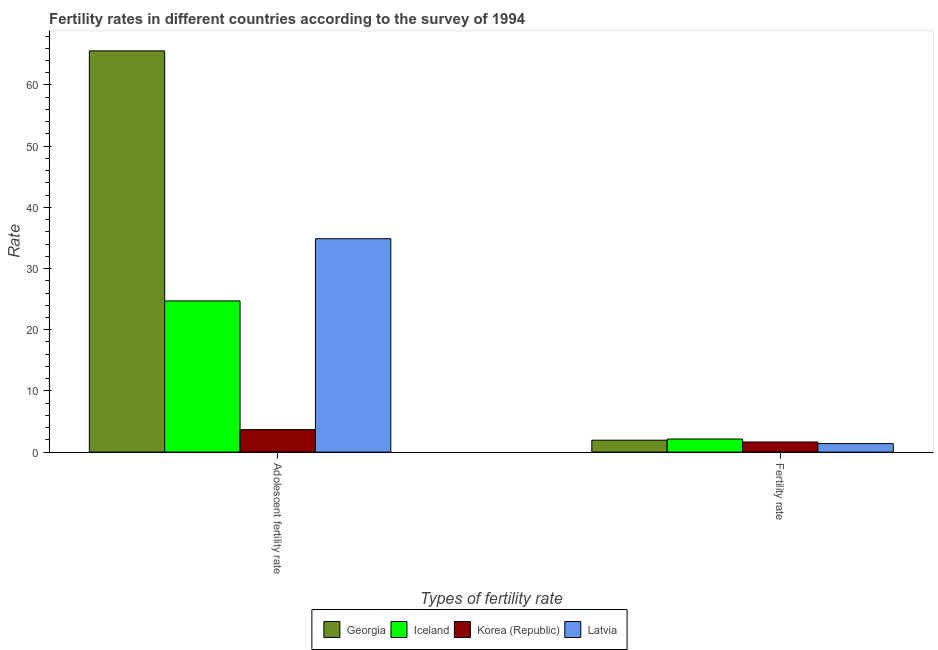How many groups of bars are there?
Your response must be concise. 2. Are the number of bars on each tick of the X-axis equal?
Give a very brief answer. Yes. What is the label of the 2nd group of bars from the left?
Keep it short and to the point. Fertility rate. What is the adolescent fertility rate in Latvia?
Offer a terse response. 34.88. Across all countries, what is the maximum fertility rate?
Your answer should be compact. 2.14. Across all countries, what is the minimum fertility rate?
Offer a very short reply. 1.39. In which country was the adolescent fertility rate maximum?
Provide a succinct answer. Georgia. In which country was the adolescent fertility rate minimum?
Keep it short and to the point. Korea (Republic). What is the total adolescent fertility rate in the graph?
Ensure brevity in your answer.  128.83. What is the difference between the adolescent fertility rate in Latvia and that in Iceland?
Offer a very short reply. 10.17. What is the difference between the fertility rate in Latvia and the adolescent fertility rate in Korea (Republic)?
Offer a very short reply. -2.29. What is the average adolescent fertility rate per country?
Give a very brief answer. 32.21. What is the difference between the adolescent fertility rate and fertility rate in Georgia?
Your answer should be very brief. 63.62. In how many countries, is the adolescent fertility rate greater than 26 ?
Give a very brief answer. 2. What is the ratio of the fertility rate in Iceland to that in Korea (Republic)?
Your answer should be compact. 1.29. Is the adolescent fertility rate in Korea (Republic) less than that in Iceland?
Provide a short and direct response. Yes. What does the 1st bar from the left in Fertility rate represents?
Your answer should be very brief. Georgia. What does the 1st bar from the right in Fertility rate represents?
Your response must be concise. Latvia. How many countries are there in the graph?
Your answer should be very brief. 4. What is the difference between two consecutive major ticks on the Y-axis?
Your answer should be very brief. 10. Where does the legend appear in the graph?
Your answer should be compact. Bottom center. What is the title of the graph?
Your answer should be very brief. Fertility rates in different countries according to the survey of 1994. Does "Qatar" appear as one of the legend labels in the graph?
Your answer should be compact. No. What is the label or title of the X-axis?
Make the answer very short. Types of fertility rate. What is the label or title of the Y-axis?
Provide a short and direct response. Rate. What is the Rate in Georgia in Adolescent fertility rate?
Your response must be concise. 65.57. What is the Rate of Iceland in Adolescent fertility rate?
Provide a short and direct response. 24.71. What is the Rate in Korea (Republic) in Adolescent fertility rate?
Keep it short and to the point. 3.68. What is the Rate in Latvia in Adolescent fertility rate?
Keep it short and to the point. 34.88. What is the Rate of Georgia in Fertility rate?
Give a very brief answer. 1.95. What is the Rate of Iceland in Fertility rate?
Offer a very short reply. 2.14. What is the Rate in Korea (Republic) in Fertility rate?
Ensure brevity in your answer.  1.66. What is the Rate in Latvia in Fertility rate?
Give a very brief answer. 1.39. Across all Types of fertility rate, what is the maximum Rate of Georgia?
Provide a short and direct response. 65.57. Across all Types of fertility rate, what is the maximum Rate of Iceland?
Make the answer very short. 24.71. Across all Types of fertility rate, what is the maximum Rate of Korea (Republic)?
Provide a short and direct response. 3.68. Across all Types of fertility rate, what is the maximum Rate of Latvia?
Keep it short and to the point. 34.88. Across all Types of fertility rate, what is the minimum Rate in Georgia?
Provide a short and direct response. 1.95. Across all Types of fertility rate, what is the minimum Rate of Iceland?
Your answer should be very brief. 2.14. Across all Types of fertility rate, what is the minimum Rate in Korea (Republic)?
Provide a succinct answer. 1.66. Across all Types of fertility rate, what is the minimum Rate in Latvia?
Offer a terse response. 1.39. What is the total Rate of Georgia in the graph?
Give a very brief answer. 67.52. What is the total Rate of Iceland in the graph?
Offer a very short reply. 26.85. What is the total Rate of Korea (Republic) in the graph?
Make the answer very short. 5.33. What is the total Rate of Latvia in the graph?
Provide a succinct answer. 36.27. What is the difference between the Rate in Georgia in Adolescent fertility rate and that in Fertility rate?
Make the answer very short. 63.62. What is the difference between the Rate of Iceland in Adolescent fertility rate and that in Fertility rate?
Keep it short and to the point. 22.57. What is the difference between the Rate of Korea (Republic) in Adolescent fertility rate and that in Fertility rate?
Keep it short and to the point. 2.02. What is the difference between the Rate of Latvia in Adolescent fertility rate and that in Fertility rate?
Keep it short and to the point. 33.49. What is the difference between the Rate in Georgia in Adolescent fertility rate and the Rate in Iceland in Fertility rate?
Make the answer very short. 63.43. What is the difference between the Rate in Georgia in Adolescent fertility rate and the Rate in Korea (Republic) in Fertility rate?
Offer a very short reply. 63.91. What is the difference between the Rate of Georgia in Adolescent fertility rate and the Rate of Latvia in Fertility rate?
Offer a very short reply. 64.18. What is the difference between the Rate of Iceland in Adolescent fertility rate and the Rate of Korea (Republic) in Fertility rate?
Give a very brief answer. 23.05. What is the difference between the Rate in Iceland in Adolescent fertility rate and the Rate in Latvia in Fertility rate?
Provide a short and direct response. 23.32. What is the difference between the Rate in Korea (Republic) in Adolescent fertility rate and the Rate in Latvia in Fertility rate?
Provide a short and direct response. 2.29. What is the average Rate in Georgia per Types of fertility rate?
Keep it short and to the point. 33.76. What is the average Rate in Iceland per Types of fertility rate?
Keep it short and to the point. 13.42. What is the average Rate in Korea (Republic) per Types of fertility rate?
Your answer should be very brief. 2.67. What is the average Rate in Latvia per Types of fertility rate?
Your answer should be very brief. 18.13. What is the difference between the Rate in Georgia and Rate in Iceland in Adolescent fertility rate?
Ensure brevity in your answer.  40.86. What is the difference between the Rate of Georgia and Rate of Korea (Republic) in Adolescent fertility rate?
Provide a short and direct response. 61.89. What is the difference between the Rate in Georgia and Rate in Latvia in Adolescent fertility rate?
Provide a short and direct response. 30.69. What is the difference between the Rate of Iceland and Rate of Korea (Republic) in Adolescent fertility rate?
Your answer should be very brief. 21.03. What is the difference between the Rate of Iceland and Rate of Latvia in Adolescent fertility rate?
Provide a succinct answer. -10.17. What is the difference between the Rate of Korea (Republic) and Rate of Latvia in Adolescent fertility rate?
Offer a terse response. -31.2. What is the difference between the Rate in Georgia and Rate in Iceland in Fertility rate?
Provide a succinct answer. -0.19. What is the difference between the Rate of Georgia and Rate of Korea (Republic) in Fertility rate?
Make the answer very short. 0.29. What is the difference between the Rate in Georgia and Rate in Latvia in Fertility rate?
Provide a succinct answer. 0.56. What is the difference between the Rate in Iceland and Rate in Korea (Republic) in Fertility rate?
Provide a short and direct response. 0.48. What is the difference between the Rate of Korea (Republic) and Rate of Latvia in Fertility rate?
Make the answer very short. 0.27. What is the ratio of the Rate in Georgia in Adolescent fertility rate to that in Fertility rate?
Keep it short and to the point. 33.69. What is the ratio of the Rate of Iceland in Adolescent fertility rate to that in Fertility rate?
Your answer should be compact. 11.55. What is the ratio of the Rate of Korea (Republic) in Adolescent fertility rate to that in Fertility rate?
Provide a short and direct response. 2.22. What is the ratio of the Rate of Latvia in Adolescent fertility rate to that in Fertility rate?
Offer a very short reply. 25.09. What is the difference between the highest and the second highest Rate in Georgia?
Offer a very short reply. 63.62. What is the difference between the highest and the second highest Rate of Iceland?
Keep it short and to the point. 22.57. What is the difference between the highest and the second highest Rate in Korea (Republic)?
Provide a succinct answer. 2.02. What is the difference between the highest and the second highest Rate of Latvia?
Provide a succinct answer. 33.49. What is the difference between the highest and the lowest Rate in Georgia?
Offer a terse response. 63.62. What is the difference between the highest and the lowest Rate of Iceland?
Your answer should be very brief. 22.57. What is the difference between the highest and the lowest Rate in Korea (Republic)?
Provide a succinct answer. 2.02. What is the difference between the highest and the lowest Rate in Latvia?
Provide a short and direct response. 33.49. 